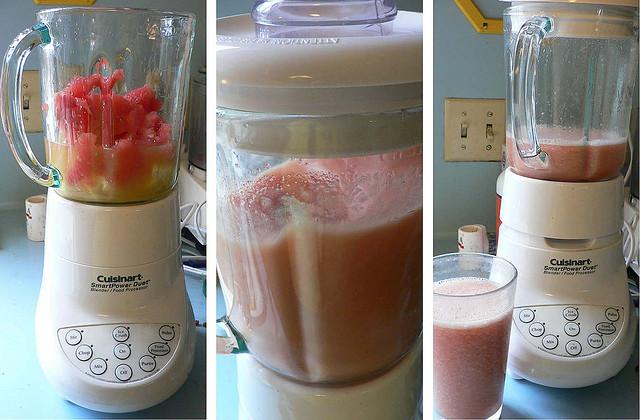Does this smoothie look delicious?
Answer briefly. Yes. What company is this blender made by?
Be succinct. Cuisinart. What is being made?
Keep it brief. Smoothie. 